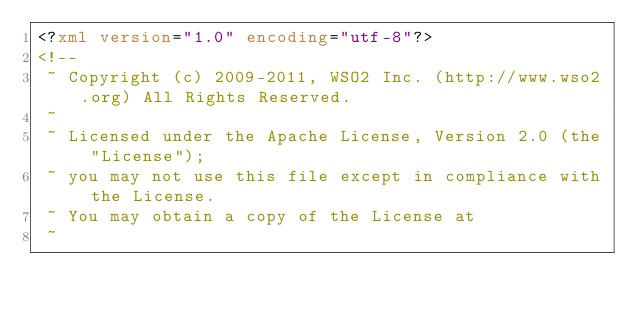Convert code to text. <code><loc_0><loc_0><loc_500><loc_500><_XML_><?xml version="1.0" encoding="utf-8"?>
<!--
 ~ Copyright (c) 2009-2011, WSO2 Inc. (http://www.wso2.org) All Rights Reserved.
 ~
 ~ Licensed under the Apache License, Version 2.0 (the "License");
 ~ you may not use this file except in compliance with the License.
 ~ You may obtain a copy of the License at
 ~</code> 